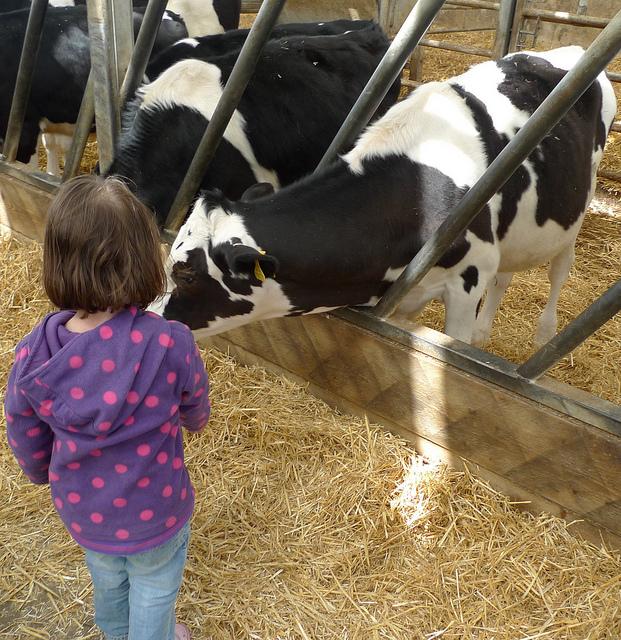How many spots on the cow?
Concise answer only. 6. Is the child a boy?
Be succinct. No. Is the girl feeding the cows?
Write a very short answer. Yes. 